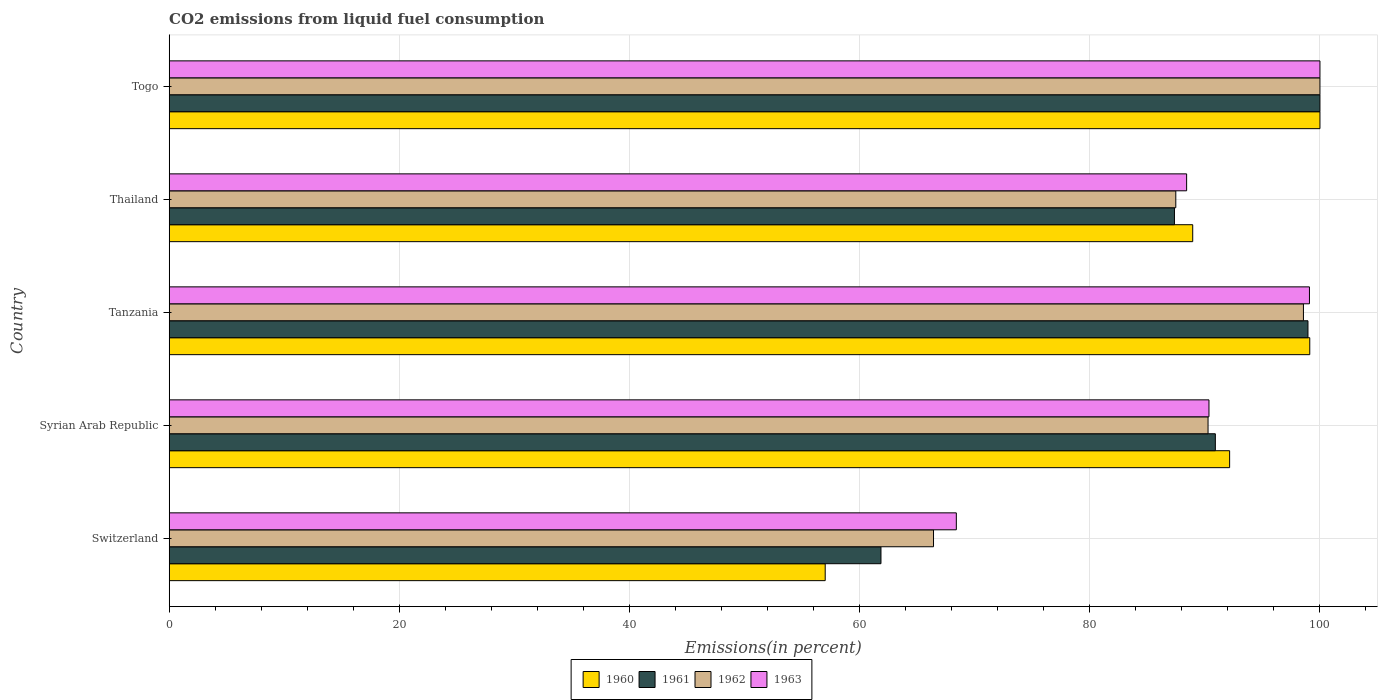How many different coloured bars are there?
Provide a succinct answer. 4. How many groups of bars are there?
Ensure brevity in your answer.  5. Are the number of bars per tick equal to the number of legend labels?
Keep it short and to the point. Yes. How many bars are there on the 3rd tick from the top?
Your answer should be very brief. 4. What is the label of the 2nd group of bars from the top?
Your response must be concise. Thailand. In how many cases, is the number of bars for a given country not equal to the number of legend labels?
Keep it short and to the point. 0. What is the total CO2 emitted in 1963 in Togo?
Your answer should be compact. 100. Across all countries, what is the minimum total CO2 emitted in 1963?
Ensure brevity in your answer.  68.4. In which country was the total CO2 emitted in 1960 maximum?
Give a very brief answer. Togo. In which country was the total CO2 emitted in 1961 minimum?
Your answer should be compact. Switzerland. What is the total total CO2 emitted in 1962 in the graph?
Your answer should be compact. 442.73. What is the difference between the total CO2 emitted in 1962 in Thailand and that in Togo?
Offer a terse response. -12.53. What is the difference between the total CO2 emitted in 1963 in Switzerland and the total CO2 emitted in 1960 in Syrian Arab Republic?
Offer a terse response. -23.75. What is the average total CO2 emitted in 1960 per country?
Keep it short and to the point. 87.44. What is the difference between the total CO2 emitted in 1961 and total CO2 emitted in 1963 in Switzerland?
Your response must be concise. -6.55. What is the ratio of the total CO2 emitted in 1962 in Syrian Arab Republic to that in Togo?
Make the answer very short. 0.9. Is the total CO2 emitted in 1962 in Tanzania less than that in Thailand?
Offer a very short reply. No. What is the difference between the highest and the second highest total CO2 emitted in 1961?
Your answer should be compact. 1.04. What is the difference between the highest and the lowest total CO2 emitted in 1961?
Offer a very short reply. 38.15. In how many countries, is the total CO2 emitted in 1961 greater than the average total CO2 emitted in 1961 taken over all countries?
Ensure brevity in your answer.  3. Is the sum of the total CO2 emitted in 1962 in Tanzania and Thailand greater than the maximum total CO2 emitted in 1963 across all countries?
Your response must be concise. Yes. Is it the case that in every country, the sum of the total CO2 emitted in 1962 and total CO2 emitted in 1963 is greater than the sum of total CO2 emitted in 1960 and total CO2 emitted in 1961?
Give a very brief answer. No. What does the 1st bar from the bottom in Togo represents?
Ensure brevity in your answer.  1960. Is it the case that in every country, the sum of the total CO2 emitted in 1963 and total CO2 emitted in 1962 is greater than the total CO2 emitted in 1960?
Offer a terse response. Yes. How many countries are there in the graph?
Your answer should be very brief. 5. Are the values on the major ticks of X-axis written in scientific E-notation?
Offer a terse response. No. Does the graph contain grids?
Your answer should be compact. Yes. How many legend labels are there?
Give a very brief answer. 4. What is the title of the graph?
Make the answer very short. CO2 emissions from liquid fuel consumption. Does "1975" appear as one of the legend labels in the graph?
Make the answer very short. No. What is the label or title of the X-axis?
Make the answer very short. Emissions(in percent). What is the label or title of the Y-axis?
Offer a very short reply. Country. What is the Emissions(in percent) in 1960 in Switzerland?
Offer a terse response. 57.01. What is the Emissions(in percent) in 1961 in Switzerland?
Your answer should be very brief. 61.85. What is the Emissions(in percent) in 1962 in Switzerland?
Your answer should be compact. 66.42. What is the Emissions(in percent) of 1963 in Switzerland?
Your answer should be very brief. 68.4. What is the Emissions(in percent) in 1960 in Syrian Arab Republic?
Give a very brief answer. 92.15. What is the Emissions(in percent) of 1961 in Syrian Arab Republic?
Provide a succinct answer. 90.91. What is the Emissions(in percent) in 1962 in Syrian Arab Republic?
Make the answer very short. 90.27. What is the Emissions(in percent) of 1963 in Syrian Arab Republic?
Give a very brief answer. 90.36. What is the Emissions(in percent) in 1960 in Tanzania?
Make the answer very short. 99.12. What is the Emissions(in percent) in 1961 in Tanzania?
Give a very brief answer. 98.96. What is the Emissions(in percent) in 1962 in Tanzania?
Your answer should be very brief. 98.56. What is the Emissions(in percent) of 1963 in Tanzania?
Offer a very short reply. 99.09. What is the Emissions(in percent) in 1960 in Thailand?
Your answer should be very brief. 88.94. What is the Emissions(in percent) in 1961 in Thailand?
Provide a short and direct response. 87.36. What is the Emissions(in percent) of 1962 in Thailand?
Your answer should be compact. 87.47. What is the Emissions(in percent) of 1963 in Thailand?
Give a very brief answer. 88.41. What is the Emissions(in percent) of 1962 in Togo?
Provide a short and direct response. 100. What is the Emissions(in percent) in 1963 in Togo?
Provide a succinct answer. 100. Across all countries, what is the maximum Emissions(in percent) in 1960?
Your answer should be very brief. 100. Across all countries, what is the maximum Emissions(in percent) in 1961?
Your answer should be very brief. 100. Across all countries, what is the maximum Emissions(in percent) of 1963?
Your answer should be very brief. 100. Across all countries, what is the minimum Emissions(in percent) in 1960?
Make the answer very short. 57.01. Across all countries, what is the minimum Emissions(in percent) in 1961?
Your answer should be compact. 61.85. Across all countries, what is the minimum Emissions(in percent) of 1962?
Offer a terse response. 66.42. Across all countries, what is the minimum Emissions(in percent) of 1963?
Make the answer very short. 68.4. What is the total Emissions(in percent) in 1960 in the graph?
Ensure brevity in your answer.  437.21. What is the total Emissions(in percent) of 1961 in the graph?
Your response must be concise. 439.08. What is the total Emissions(in percent) in 1962 in the graph?
Your response must be concise. 442.73. What is the total Emissions(in percent) of 1963 in the graph?
Ensure brevity in your answer.  446.26. What is the difference between the Emissions(in percent) in 1960 in Switzerland and that in Syrian Arab Republic?
Offer a terse response. -35.14. What is the difference between the Emissions(in percent) of 1961 in Switzerland and that in Syrian Arab Republic?
Ensure brevity in your answer.  -29.06. What is the difference between the Emissions(in percent) of 1962 in Switzerland and that in Syrian Arab Republic?
Ensure brevity in your answer.  -23.86. What is the difference between the Emissions(in percent) in 1963 in Switzerland and that in Syrian Arab Republic?
Offer a terse response. -21.95. What is the difference between the Emissions(in percent) of 1960 in Switzerland and that in Tanzania?
Provide a short and direct response. -42.11. What is the difference between the Emissions(in percent) of 1961 in Switzerland and that in Tanzania?
Keep it short and to the point. -37.11. What is the difference between the Emissions(in percent) in 1962 in Switzerland and that in Tanzania?
Offer a terse response. -32.15. What is the difference between the Emissions(in percent) of 1963 in Switzerland and that in Tanzania?
Offer a very short reply. -30.69. What is the difference between the Emissions(in percent) in 1960 in Switzerland and that in Thailand?
Give a very brief answer. -31.94. What is the difference between the Emissions(in percent) in 1961 in Switzerland and that in Thailand?
Your response must be concise. -25.5. What is the difference between the Emissions(in percent) of 1962 in Switzerland and that in Thailand?
Make the answer very short. -21.05. What is the difference between the Emissions(in percent) in 1963 in Switzerland and that in Thailand?
Offer a very short reply. -20.01. What is the difference between the Emissions(in percent) in 1960 in Switzerland and that in Togo?
Your response must be concise. -42.99. What is the difference between the Emissions(in percent) of 1961 in Switzerland and that in Togo?
Offer a terse response. -38.15. What is the difference between the Emissions(in percent) in 1962 in Switzerland and that in Togo?
Offer a very short reply. -33.58. What is the difference between the Emissions(in percent) of 1963 in Switzerland and that in Togo?
Your response must be concise. -31.6. What is the difference between the Emissions(in percent) of 1960 in Syrian Arab Republic and that in Tanzania?
Your response must be concise. -6.96. What is the difference between the Emissions(in percent) in 1961 in Syrian Arab Republic and that in Tanzania?
Your answer should be compact. -8.05. What is the difference between the Emissions(in percent) of 1962 in Syrian Arab Republic and that in Tanzania?
Your response must be concise. -8.29. What is the difference between the Emissions(in percent) of 1963 in Syrian Arab Republic and that in Tanzania?
Your answer should be very brief. -8.73. What is the difference between the Emissions(in percent) of 1960 in Syrian Arab Republic and that in Thailand?
Offer a very short reply. 3.21. What is the difference between the Emissions(in percent) in 1961 in Syrian Arab Republic and that in Thailand?
Your response must be concise. 3.55. What is the difference between the Emissions(in percent) of 1962 in Syrian Arab Republic and that in Thailand?
Your response must be concise. 2.8. What is the difference between the Emissions(in percent) of 1963 in Syrian Arab Republic and that in Thailand?
Your answer should be compact. 1.94. What is the difference between the Emissions(in percent) in 1960 in Syrian Arab Republic and that in Togo?
Your response must be concise. -7.85. What is the difference between the Emissions(in percent) in 1961 in Syrian Arab Republic and that in Togo?
Ensure brevity in your answer.  -9.09. What is the difference between the Emissions(in percent) of 1962 in Syrian Arab Republic and that in Togo?
Provide a succinct answer. -9.73. What is the difference between the Emissions(in percent) of 1963 in Syrian Arab Republic and that in Togo?
Your answer should be very brief. -9.64. What is the difference between the Emissions(in percent) in 1960 in Tanzania and that in Thailand?
Provide a succinct answer. 10.17. What is the difference between the Emissions(in percent) of 1961 in Tanzania and that in Thailand?
Your answer should be very brief. 11.6. What is the difference between the Emissions(in percent) in 1962 in Tanzania and that in Thailand?
Your answer should be very brief. 11.09. What is the difference between the Emissions(in percent) in 1963 in Tanzania and that in Thailand?
Offer a terse response. 10.67. What is the difference between the Emissions(in percent) of 1960 in Tanzania and that in Togo?
Make the answer very short. -0.89. What is the difference between the Emissions(in percent) in 1961 in Tanzania and that in Togo?
Keep it short and to the point. -1.04. What is the difference between the Emissions(in percent) of 1962 in Tanzania and that in Togo?
Provide a succinct answer. -1.44. What is the difference between the Emissions(in percent) in 1963 in Tanzania and that in Togo?
Keep it short and to the point. -0.91. What is the difference between the Emissions(in percent) of 1960 in Thailand and that in Togo?
Provide a succinct answer. -11.06. What is the difference between the Emissions(in percent) of 1961 in Thailand and that in Togo?
Offer a terse response. -12.64. What is the difference between the Emissions(in percent) in 1962 in Thailand and that in Togo?
Your answer should be compact. -12.53. What is the difference between the Emissions(in percent) in 1963 in Thailand and that in Togo?
Your answer should be compact. -11.59. What is the difference between the Emissions(in percent) of 1960 in Switzerland and the Emissions(in percent) of 1961 in Syrian Arab Republic?
Offer a very short reply. -33.9. What is the difference between the Emissions(in percent) in 1960 in Switzerland and the Emissions(in percent) in 1962 in Syrian Arab Republic?
Offer a very short reply. -33.27. What is the difference between the Emissions(in percent) of 1960 in Switzerland and the Emissions(in percent) of 1963 in Syrian Arab Republic?
Make the answer very short. -33.35. What is the difference between the Emissions(in percent) of 1961 in Switzerland and the Emissions(in percent) of 1962 in Syrian Arab Republic?
Provide a short and direct response. -28.42. What is the difference between the Emissions(in percent) of 1961 in Switzerland and the Emissions(in percent) of 1963 in Syrian Arab Republic?
Your answer should be very brief. -28.5. What is the difference between the Emissions(in percent) of 1962 in Switzerland and the Emissions(in percent) of 1963 in Syrian Arab Republic?
Offer a terse response. -23.94. What is the difference between the Emissions(in percent) of 1960 in Switzerland and the Emissions(in percent) of 1961 in Tanzania?
Provide a short and direct response. -41.95. What is the difference between the Emissions(in percent) of 1960 in Switzerland and the Emissions(in percent) of 1962 in Tanzania?
Provide a short and direct response. -41.56. What is the difference between the Emissions(in percent) in 1960 in Switzerland and the Emissions(in percent) in 1963 in Tanzania?
Your answer should be compact. -42.08. What is the difference between the Emissions(in percent) in 1961 in Switzerland and the Emissions(in percent) in 1962 in Tanzania?
Provide a succinct answer. -36.71. What is the difference between the Emissions(in percent) of 1961 in Switzerland and the Emissions(in percent) of 1963 in Tanzania?
Ensure brevity in your answer.  -37.23. What is the difference between the Emissions(in percent) in 1962 in Switzerland and the Emissions(in percent) in 1963 in Tanzania?
Your answer should be very brief. -32.67. What is the difference between the Emissions(in percent) in 1960 in Switzerland and the Emissions(in percent) in 1961 in Thailand?
Provide a short and direct response. -30.35. What is the difference between the Emissions(in percent) in 1960 in Switzerland and the Emissions(in percent) in 1962 in Thailand?
Provide a succinct answer. -30.47. What is the difference between the Emissions(in percent) in 1960 in Switzerland and the Emissions(in percent) in 1963 in Thailand?
Provide a succinct answer. -31.41. What is the difference between the Emissions(in percent) of 1961 in Switzerland and the Emissions(in percent) of 1962 in Thailand?
Offer a terse response. -25.62. What is the difference between the Emissions(in percent) of 1961 in Switzerland and the Emissions(in percent) of 1963 in Thailand?
Offer a terse response. -26.56. What is the difference between the Emissions(in percent) in 1962 in Switzerland and the Emissions(in percent) in 1963 in Thailand?
Keep it short and to the point. -21.99. What is the difference between the Emissions(in percent) in 1960 in Switzerland and the Emissions(in percent) in 1961 in Togo?
Provide a succinct answer. -42.99. What is the difference between the Emissions(in percent) in 1960 in Switzerland and the Emissions(in percent) in 1962 in Togo?
Your response must be concise. -42.99. What is the difference between the Emissions(in percent) in 1960 in Switzerland and the Emissions(in percent) in 1963 in Togo?
Your answer should be compact. -42.99. What is the difference between the Emissions(in percent) in 1961 in Switzerland and the Emissions(in percent) in 1962 in Togo?
Provide a succinct answer. -38.15. What is the difference between the Emissions(in percent) in 1961 in Switzerland and the Emissions(in percent) in 1963 in Togo?
Provide a short and direct response. -38.15. What is the difference between the Emissions(in percent) of 1962 in Switzerland and the Emissions(in percent) of 1963 in Togo?
Your response must be concise. -33.58. What is the difference between the Emissions(in percent) of 1960 in Syrian Arab Republic and the Emissions(in percent) of 1961 in Tanzania?
Keep it short and to the point. -6.81. What is the difference between the Emissions(in percent) of 1960 in Syrian Arab Republic and the Emissions(in percent) of 1962 in Tanzania?
Offer a terse response. -6.41. What is the difference between the Emissions(in percent) in 1960 in Syrian Arab Republic and the Emissions(in percent) in 1963 in Tanzania?
Your response must be concise. -6.94. What is the difference between the Emissions(in percent) in 1961 in Syrian Arab Republic and the Emissions(in percent) in 1962 in Tanzania?
Provide a succinct answer. -7.66. What is the difference between the Emissions(in percent) in 1961 in Syrian Arab Republic and the Emissions(in percent) in 1963 in Tanzania?
Your answer should be very brief. -8.18. What is the difference between the Emissions(in percent) in 1962 in Syrian Arab Republic and the Emissions(in percent) in 1963 in Tanzania?
Provide a short and direct response. -8.81. What is the difference between the Emissions(in percent) of 1960 in Syrian Arab Republic and the Emissions(in percent) of 1961 in Thailand?
Provide a short and direct response. 4.79. What is the difference between the Emissions(in percent) in 1960 in Syrian Arab Republic and the Emissions(in percent) in 1962 in Thailand?
Keep it short and to the point. 4.68. What is the difference between the Emissions(in percent) in 1960 in Syrian Arab Republic and the Emissions(in percent) in 1963 in Thailand?
Give a very brief answer. 3.74. What is the difference between the Emissions(in percent) of 1961 in Syrian Arab Republic and the Emissions(in percent) of 1962 in Thailand?
Offer a very short reply. 3.44. What is the difference between the Emissions(in percent) of 1961 in Syrian Arab Republic and the Emissions(in percent) of 1963 in Thailand?
Offer a terse response. 2.5. What is the difference between the Emissions(in percent) in 1962 in Syrian Arab Republic and the Emissions(in percent) in 1963 in Thailand?
Your answer should be very brief. 1.86. What is the difference between the Emissions(in percent) in 1960 in Syrian Arab Republic and the Emissions(in percent) in 1961 in Togo?
Provide a short and direct response. -7.85. What is the difference between the Emissions(in percent) in 1960 in Syrian Arab Republic and the Emissions(in percent) in 1962 in Togo?
Your response must be concise. -7.85. What is the difference between the Emissions(in percent) of 1960 in Syrian Arab Republic and the Emissions(in percent) of 1963 in Togo?
Ensure brevity in your answer.  -7.85. What is the difference between the Emissions(in percent) of 1961 in Syrian Arab Republic and the Emissions(in percent) of 1962 in Togo?
Make the answer very short. -9.09. What is the difference between the Emissions(in percent) in 1961 in Syrian Arab Republic and the Emissions(in percent) in 1963 in Togo?
Provide a succinct answer. -9.09. What is the difference between the Emissions(in percent) of 1962 in Syrian Arab Republic and the Emissions(in percent) of 1963 in Togo?
Provide a short and direct response. -9.73. What is the difference between the Emissions(in percent) in 1960 in Tanzania and the Emissions(in percent) in 1961 in Thailand?
Offer a very short reply. 11.76. What is the difference between the Emissions(in percent) in 1960 in Tanzania and the Emissions(in percent) in 1962 in Thailand?
Ensure brevity in your answer.  11.64. What is the difference between the Emissions(in percent) of 1960 in Tanzania and the Emissions(in percent) of 1963 in Thailand?
Provide a succinct answer. 10.7. What is the difference between the Emissions(in percent) in 1961 in Tanzania and the Emissions(in percent) in 1962 in Thailand?
Provide a succinct answer. 11.49. What is the difference between the Emissions(in percent) in 1961 in Tanzania and the Emissions(in percent) in 1963 in Thailand?
Your response must be concise. 10.54. What is the difference between the Emissions(in percent) in 1962 in Tanzania and the Emissions(in percent) in 1963 in Thailand?
Give a very brief answer. 10.15. What is the difference between the Emissions(in percent) of 1960 in Tanzania and the Emissions(in percent) of 1961 in Togo?
Provide a succinct answer. -0.89. What is the difference between the Emissions(in percent) in 1960 in Tanzania and the Emissions(in percent) in 1962 in Togo?
Provide a succinct answer. -0.89. What is the difference between the Emissions(in percent) of 1960 in Tanzania and the Emissions(in percent) of 1963 in Togo?
Make the answer very short. -0.89. What is the difference between the Emissions(in percent) of 1961 in Tanzania and the Emissions(in percent) of 1962 in Togo?
Your answer should be very brief. -1.04. What is the difference between the Emissions(in percent) in 1961 in Tanzania and the Emissions(in percent) in 1963 in Togo?
Offer a terse response. -1.04. What is the difference between the Emissions(in percent) of 1962 in Tanzania and the Emissions(in percent) of 1963 in Togo?
Your response must be concise. -1.44. What is the difference between the Emissions(in percent) in 1960 in Thailand and the Emissions(in percent) in 1961 in Togo?
Offer a very short reply. -11.06. What is the difference between the Emissions(in percent) in 1960 in Thailand and the Emissions(in percent) in 1962 in Togo?
Offer a terse response. -11.06. What is the difference between the Emissions(in percent) of 1960 in Thailand and the Emissions(in percent) of 1963 in Togo?
Give a very brief answer. -11.06. What is the difference between the Emissions(in percent) of 1961 in Thailand and the Emissions(in percent) of 1962 in Togo?
Give a very brief answer. -12.64. What is the difference between the Emissions(in percent) of 1961 in Thailand and the Emissions(in percent) of 1963 in Togo?
Provide a succinct answer. -12.64. What is the difference between the Emissions(in percent) in 1962 in Thailand and the Emissions(in percent) in 1963 in Togo?
Provide a succinct answer. -12.53. What is the average Emissions(in percent) in 1960 per country?
Provide a short and direct response. 87.44. What is the average Emissions(in percent) in 1961 per country?
Your response must be concise. 87.82. What is the average Emissions(in percent) in 1962 per country?
Give a very brief answer. 88.55. What is the average Emissions(in percent) in 1963 per country?
Your answer should be very brief. 89.25. What is the difference between the Emissions(in percent) in 1960 and Emissions(in percent) in 1961 in Switzerland?
Offer a very short reply. -4.85. What is the difference between the Emissions(in percent) in 1960 and Emissions(in percent) in 1962 in Switzerland?
Ensure brevity in your answer.  -9.41. What is the difference between the Emissions(in percent) of 1960 and Emissions(in percent) of 1963 in Switzerland?
Give a very brief answer. -11.4. What is the difference between the Emissions(in percent) of 1961 and Emissions(in percent) of 1962 in Switzerland?
Give a very brief answer. -4.57. What is the difference between the Emissions(in percent) in 1961 and Emissions(in percent) in 1963 in Switzerland?
Provide a succinct answer. -6.55. What is the difference between the Emissions(in percent) of 1962 and Emissions(in percent) of 1963 in Switzerland?
Offer a very short reply. -1.98. What is the difference between the Emissions(in percent) in 1960 and Emissions(in percent) in 1961 in Syrian Arab Republic?
Your response must be concise. 1.24. What is the difference between the Emissions(in percent) in 1960 and Emissions(in percent) in 1962 in Syrian Arab Republic?
Offer a terse response. 1.88. What is the difference between the Emissions(in percent) of 1960 and Emissions(in percent) of 1963 in Syrian Arab Republic?
Your answer should be very brief. 1.79. What is the difference between the Emissions(in percent) of 1961 and Emissions(in percent) of 1962 in Syrian Arab Republic?
Make the answer very short. 0.63. What is the difference between the Emissions(in percent) in 1961 and Emissions(in percent) in 1963 in Syrian Arab Republic?
Offer a terse response. 0.55. What is the difference between the Emissions(in percent) of 1962 and Emissions(in percent) of 1963 in Syrian Arab Republic?
Offer a very short reply. -0.08. What is the difference between the Emissions(in percent) in 1960 and Emissions(in percent) in 1961 in Tanzania?
Provide a short and direct response. 0.16. What is the difference between the Emissions(in percent) in 1960 and Emissions(in percent) in 1962 in Tanzania?
Provide a succinct answer. 0.55. What is the difference between the Emissions(in percent) in 1960 and Emissions(in percent) in 1963 in Tanzania?
Your answer should be very brief. 0.03. What is the difference between the Emissions(in percent) of 1961 and Emissions(in percent) of 1962 in Tanzania?
Your response must be concise. 0.39. What is the difference between the Emissions(in percent) of 1961 and Emissions(in percent) of 1963 in Tanzania?
Your answer should be compact. -0.13. What is the difference between the Emissions(in percent) in 1962 and Emissions(in percent) in 1963 in Tanzania?
Offer a very short reply. -0.52. What is the difference between the Emissions(in percent) in 1960 and Emissions(in percent) in 1961 in Thailand?
Your answer should be very brief. 1.59. What is the difference between the Emissions(in percent) of 1960 and Emissions(in percent) of 1962 in Thailand?
Offer a very short reply. 1.47. What is the difference between the Emissions(in percent) in 1960 and Emissions(in percent) in 1963 in Thailand?
Your answer should be compact. 0.53. What is the difference between the Emissions(in percent) in 1961 and Emissions(in percent) in 1962 in Thailand?
Keep it short and to the point. -0.12. What is the difference between the Emissions(in percent) of 1961 and Emissions(in percent) of 1963 in Thailand?
Keep it short and to the point. -1.06. What is the difference between the Emissions(in percent) in 1962 and Emissions(in percent) in 1963 in Thailand?
Give a very brief answer. -0.94. What is the difference between the Emissions(in percent) in 1960 and Emissions(in percent) in 1961 in Togo?
Provide a short and direct response. 0. What is the difference between the Emissions(in percent) in 1960 and Emissions(in percent) in 1962 in Togo?
Your answer should be compact. 0. What is the difference between the Emissions(in percent) in 1960 and Emissions(in percent) in 1963 in Togo?
Provide a succinct answer. 0. What is the difference between the Emissions(in percent) in 1961 and Emissions(in percent) in 1962 in Togo?
Keep it short and to the point. 0. What is the difference between the Emissions(in percent) of 1961 and Emissions(in percent) of 1963 in Togo?
Give a very brief answer. 0. What is the ratio of the Emissions(in percent) in 1960 in Switzerland to that in Syrian Arab Republic?
Your answer should be compact. 0.62. What is the ratio of the Emissions(in percent) of 1961 in Switzerland to that in Syrian Arab Republic?
Your answer should be compact. 0.68. What is the ratio of the Emissions(in percent) in 1962 in Switzerland to that in Syrian Arab Republic?
Your answer should be very brief. 0.74. What is the ratio of the Emissions(in percent) of 1963 in Switzerland to that in Syrian Arab Republic?
Keep it short and to the point. 0.76. What is the ratio of the Emissions(in percent) of 1960 in Switzerland to that in Tanzania?
Ensure brevity in your answer.  0.58. What is the ratio of the Emissions(in percent) in 1962 in Switzerland to that in Tanzania?
Offer a very short reply. 0.67. What is the ratio of the Emissions(in percent) of 1963 in Switzerland to that in Tanzania?
Keep it short and to the point. 0.69. What is the ratio of the Emissions(in percent) of 1960 in Switzerland to that in Thailand?
Your answer should be compact. 0.64. What is the ratio of the Emissions(in percent) of 1961 in Switzerland to that in Thailand?
Your response must be concise. 0.71. What is the ratio of the Emissions(in percent) in 1962 in Switzerland to that in Thailand?
Make the answer very short. 0.76. What is the ratio of the Emissions(in percent) in 1963 in Switzerland to that in Thailand?
Your answer should be compact. 0.77. What is the ratio of the Emissions(in percent) of 1960 in Switzerland to that in Togo?
Ensure brevity in your answer.  0.57. What is the ratio of the Emissions(in percent) in 1961 in Switzerland to that in Togo?
Keep it short and to the point. 0.62. What is the ratio of the Emissions(in percent) in 1962 in Switzerland to that in Togo?
Your answer should be compact. 0.66. What is the ratio of the Emissions(in percent) in 1963 in Switzerland to that in Togo?
Provide a succinct answer. 0.68. What is the ratio of the Emissions(in percent) of 1960 in Syrian Arab Republic to that in Tanzania?
Provide a short and direct response. 0.93. What is the ratio of the Emissions(in percent) in 1961 in Syrian Arab Republic to that in Tanzania?
Give a very brief answer. 0.92. What is the ratio of the Emissions(in percent) in 1962 in Syrian Arab Republic to that in Tanzania?
Give a very brief answer. 0.92. What is the ratio of the Emissions(in percent) in 1963 in Syrian Arab Republic to that in Tanzania?
Provide a short and direct response. 0.91. What is the ratio of the Emissions(in percent) of 1960 in Syrian Arab Republic to that in Thailand?
Offer a very short reply. 1.04. What is the ratio of the Emissions(in percent) in 1961 in Syrian Arab Republic to that in Thailand?
Keep it short and to the point. 1.04. What is the ratio of the Emissions(in percent) in 1962 in Syrian Arab Republic to that in Thailand?
Offer a very short reply. 1.03. What is the ratio of the Emissions(in percent) in 1963 in Syrian Arab Republic to that in Thailand?
Provide a short and direct response. 1.02. What is the ratio of the Emissions(in percent) of 1960 in Syrian Arab Republic to that in Togo?
Your answer should be very brief. 0.92. What is the ratio of the Emissions(in percent) in 1961 in Syrian Arab Republic to that in Togo?
Your response must be concise. 0.91. What is the ratio of the Emissions(in percent) in 1962 in Syrian Arab Republic to that in Togo?
Offer a very short reply. 0.9. What is the ratio of the Emissions(in percent) of 1963 in Syrian Arab Republic to that in Togo?
Make the answer very short. 0.9. What is the ratio of the Emissions(in percent) in 1960 in Tanzania to that in Thailand?
Your answer should be compact. 1.11. What is the ratio of the Emissions(in percent) of 1961 in Tanzania to that in Thailand?
Provide a short and direct response. 1.13. What is the ratio of the Emissions(in percent) in 1962 in Tanzania to that in Thailand?
Ensure brevity in your answer.  1.13. What is the ratio of the Emissions(in percent) of 1963 in Tanzania to that in Thailand?
Your answer should be compact. 1.12. What is the ratio of the Emissions(in percent) in 1960 in Tanzania to that in Togo?
Your answer should be very brief. 0.99. What is the ratio of the Emissions(in percent) of 1962 in Tanzania to that in Togo?
Make the answer very short. 0.99. What is the ratio of the Emissions(in percent) in 1963 in Tanzania to that in Togo?
Your answer should be very brief. 0.99. What is the ratio of the Emissions(in percent) of 1960 in Thailand to that in Togo?
Keep it short and to the point. 0.89. What is the ratio of the Emissions(in percent) in 1961 in Thailand to that in Togo?
Offer a very short reply. 0.87. What is the ratio of the Emissions(in percent) of 1962 in Thailand to that in Togo?
Ensure brevity in your answer.  0.87. What is the ratio of the Emissions(in percent) of 1963 in Thailand to that in Togo?
Provide a succinct answer. 0.88. What is the difference between the highest and the second highest Emissions(in percent) in 1960?
Provide a short and direct response. 0.89. What is the difference between the highest and the second highest Emissions(in percent) in 1961?
Your answer should be compact. 1.04. What is the difference between the highest and the second highest Emissions(in percent) in 1962?
Your answer should be compact. 1.44. What is the difference between the highest and the second highest Emissions(in percent) of 1963?
Offer a terse response. 0.91. What is the difference between the highest and the lowest Emissions(in percent) in 1960?
Your answer should be very brief. 42.99. What is the difference between the highest and the lowest Emissions(in percent) in 1961?
Your answer should be very brief. 38.15. What is the difference between the highest and the lowest Emissions(in percent) of 1962?
Your answer should be compact. 33.58. What is the difference between the highest and the lowest Emissions(in percent) of 1963?
Offer a terse response. 31.6. 